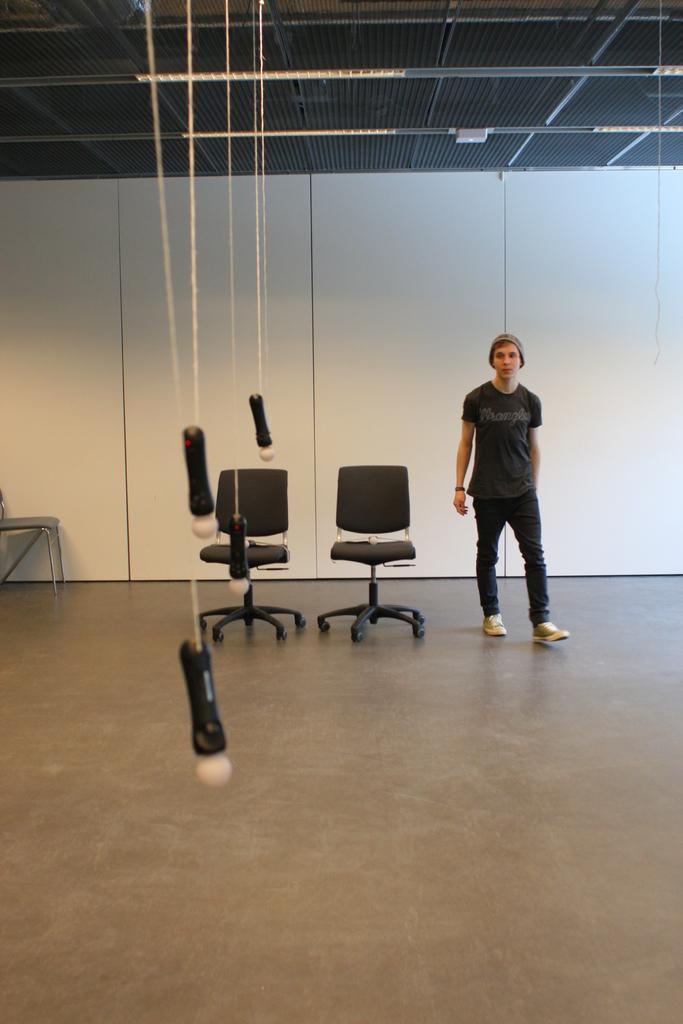How would you summarize this image in a sentence or two? The person wearing black dress is standing and there are two black chairs beside him and there are ropes tied to an object in front of him. 